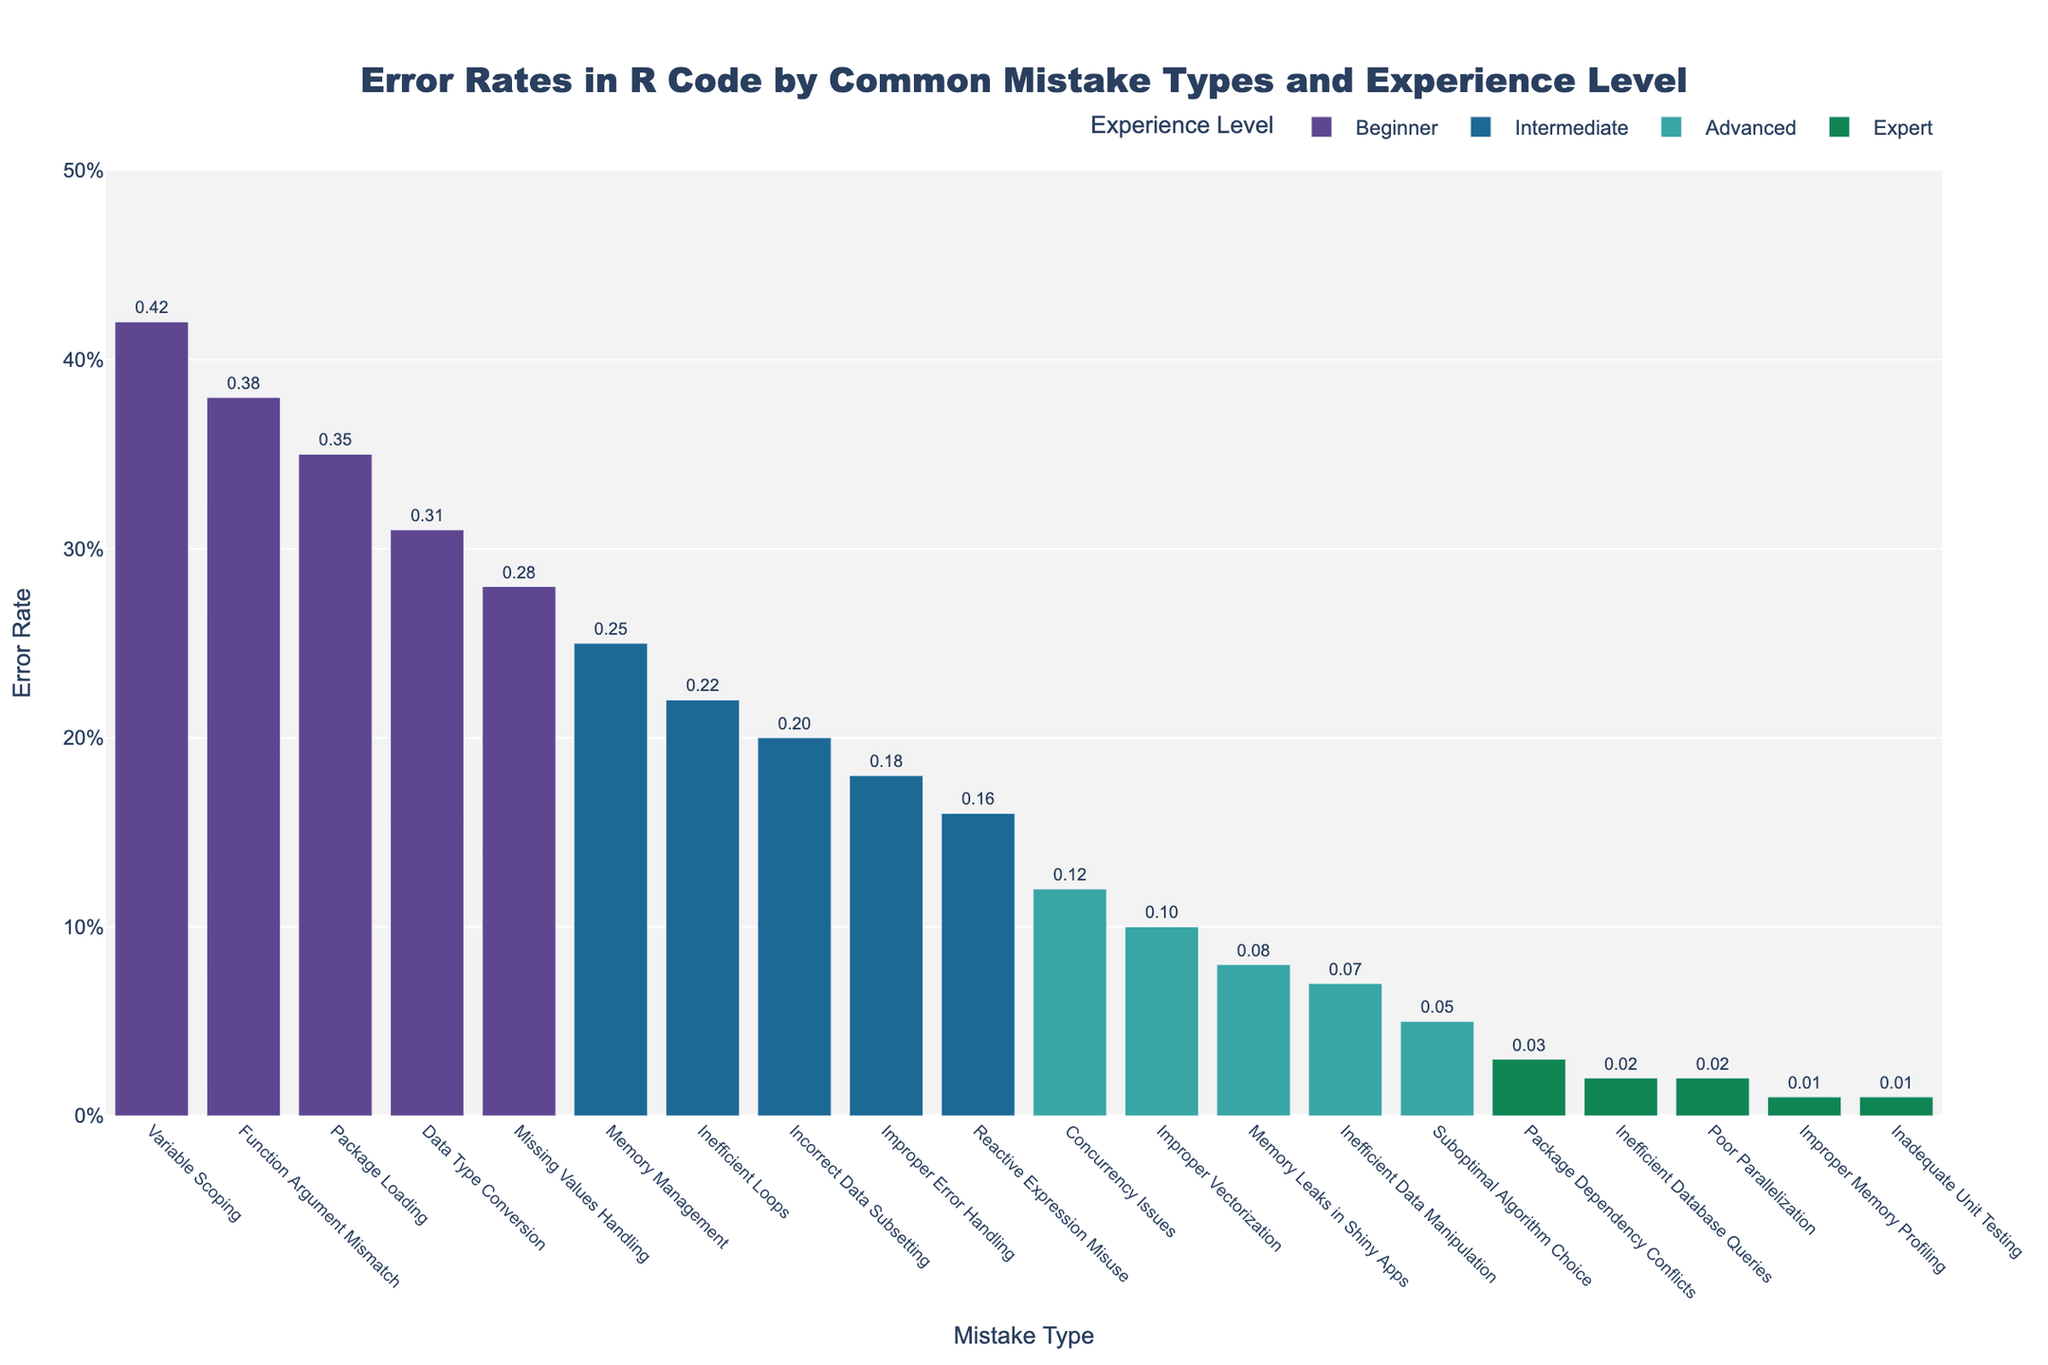What is the error rate for 'Missing Values Handling' for beginners? Locate the bar for 'Missing Values Handling' under the beginner category. The text value provides the error rate.
Answer: 0.28 Which mistake type has the lowest error rate among experts? Identify all bars for the expert category and find the shortest one. The category label and text value will indicate the mistake type and error rate.
Answer: Inadequate Unit Testing, 0.01 What is the total error rate for 'Beginner' level mistakes? Sum all error rates for the beginner category: 0.42 + 0.38 + 0.35 + 0.31 + 0.28
Answer: 1.74 Compare the error rate of 'Memory Management' for intermediate programmers to 'Package Loading' for beginners. Which is higher? Locate and compare the heights of the bars for 'Memory Management' under intermediate and 'Package Loading' under beginner. 'Package Loading' shows higher error rate (0.35) compared to 'Memory Management' (0.25).
Answer: Package Loading Which experience level has the largest spread between the highest and lowest error rates? Calculate the difference between the highest and lowest error rates for each experience level: Beginner (0.42 - 0.28 = 0.14), Intermediate (0.25 - 0.16 = 0.09), Advanced (0.12 - 0.05 = 0.07), Expert (0.03 - 0.01 = 0.02). The largest spread is for Beginners.
Answer: Beginner What is the average error rate for 'Improper Vectorization' across all experience levels? First identify the error rates for 'Improper Vectorization'. Only Advanced category lists it: 0.10. Since it's only present in one category, its average is itself.
Answer: 0.10 How does the error rate for 'Suboptimal Algorithm Choice' in Advanced programmers compare to the highest error rate for Intermediate programmers? 'Suboptimal Algorithm Choice' has an error rate of 0.05. The highest error rate for Intermediate is 'Memory Management' at 0.25. Thus, 0.05 is lower than 0.25.
Answer: Lower Which experience level and mistake type combination has an error rate of 0.22? Locate the bar that matches the error rate of 0.22. This is under Intermediate level for 'Inefficient Loops'.
Answer: Intermediate, Inefficient Loops 